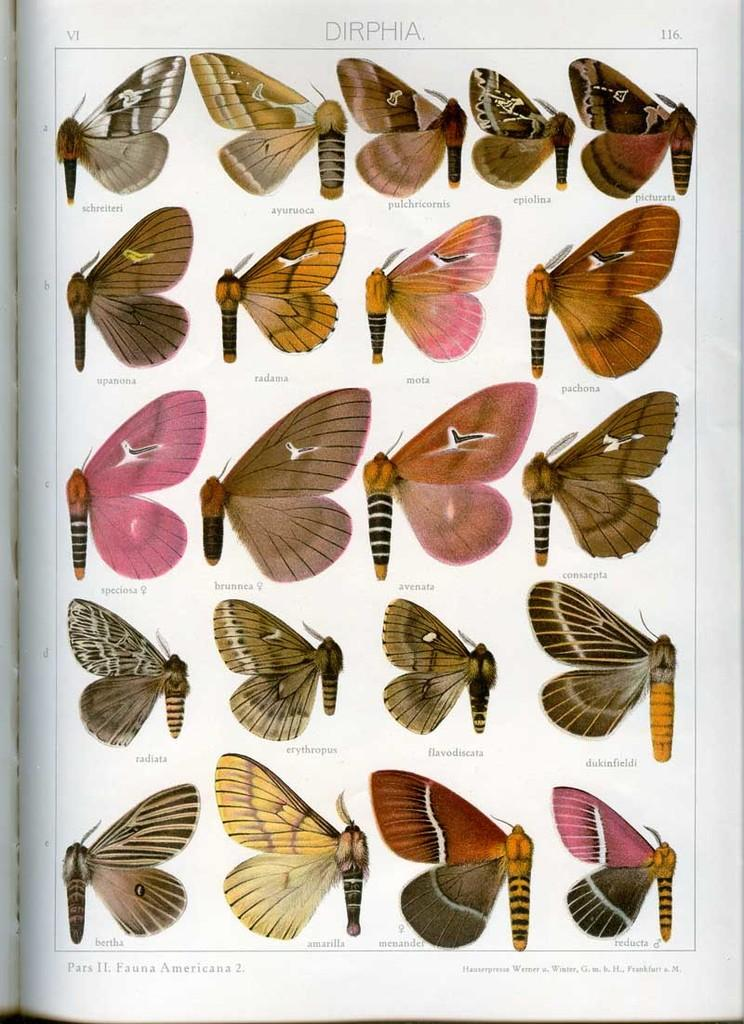What is present on the paper in the image? There are words, numbers, and images of butterflies on the paper. Can you describe the content of the paper? The paper contains a combination of words, numbers, and butterfly images. What color is the paint used to create the butterflies on the paper? There is no paint present on the paper; the butterflies are images, not painted. 